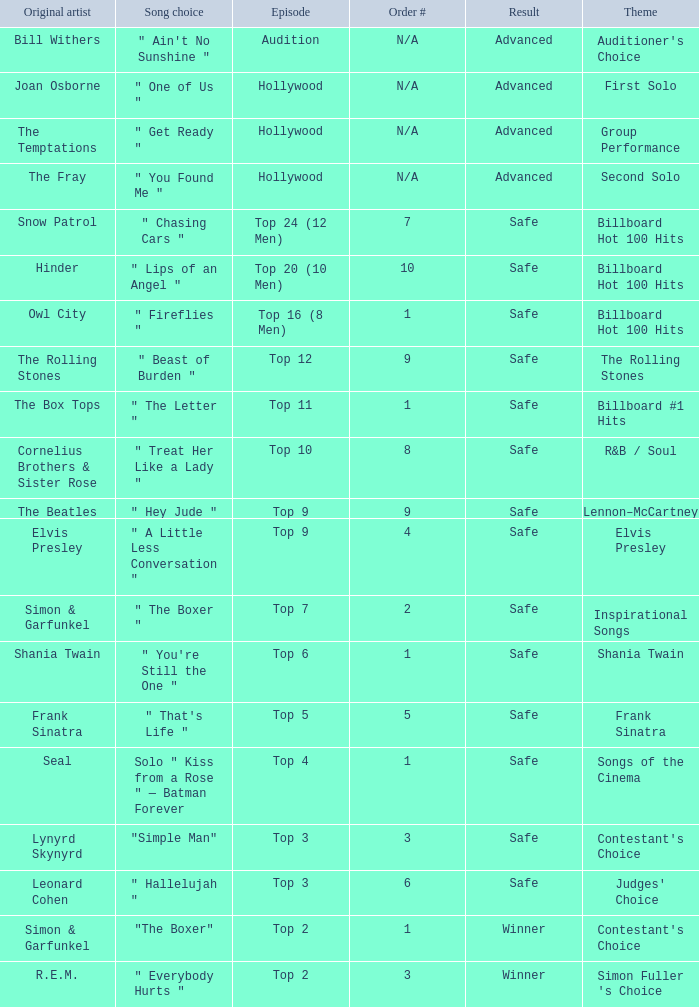In which episode is the order number 10? Top 20 (10 Men). Parse the full table. {'header': ['Original artist', 'Song choice', 'Episode', 'Order #', 'Result', 'Theme'], 'rows': [['Bill Withers', '" Ain\'t No Sunshine "', 'Audition', 'N/A', 'Advanced', "Auditioner's Choice"], ['Joan Osborne', '" One of Us "', 'Hollywood', 'N/A', 'Advanced', 'First Solo'], ['The Temptations', '" Get Ready "', 'Hollywood', 'N/A', 'Advanced', 'Group Performance'], ['The Fray', '" You Found Me "', 'Hollywood', 'N/A', 'Advanced', 'Second Solo'], ['Snow Patrol', '" Chasing Cars "', 'Top 24 (12 Men)', '7', 'Safe', 'Billboard Hot 100 Hits'], ['Hinder', '" Lips of an Angel "', 'Top 20 (10 Men)', '10', 'Safe', 'Billboard Hot 100 Hits'], ['Owl City', '" Fireflies "', 'Top 16 (8 Men)', '1', 'Safe', 'Billboard Hot 100 Hits'], ['The Rolling Stones', '" Beast of Burden "', 'Top 12', '9', 'Safe', 'The Rolling Stones'], ['The Box Tops', '" The Letter "', 'Top 11', '1', 'Safe', 'Billboard #1 Hits'], ['Cornelius Brothers & Sister Rose', '" Treat Her Like a Lady "', 'Top 10', '8', 'Safe', 'R&B / Soul'], ['The Beatles', '" Hey Jude "', 'Top 9', '9', 'Safe', 'Lennon–McCartney'], ['Elvis Presley', '" A Little Less Conversation "', 'Top 9', '4', 'Safe', 'Elvis Presley'], ['Simon & Garfunkel', '" The Boxer "', 'Top 7', '2', 'Safe', 'Inspirational Songs'], ['Shania Twain', '" You\'re Still the One "', 'Top 6', '1', 'Safe', 'Shania Twain'], ['Frank Sinatra', '" That\'s Life "', 'Top 5', '5', 'Safe', 'Frank Sinatra'], ['Seal', 'Solo " Kiss from a Rose " — Batman Forever', 'Top 4', '1', 'Safe', 'Songs of the Cinema'], ['Lynyrd Skynyrd', '"Simple Man"', 'Top 3', '3', 'Safe', "Contestant's Choice"], ['Leonard Cohen', '" Hallelujah "', 'Top 3', '6', 'Safe', "Judges' Choice"], ['Simon & Garfunkel', '"The Boxer"', 'Top 2', '1', 'Winner', "Contestant's Choice"], ['R.E.M.', '" Everybody Hurts "', 'Top 2', '3', 'Winner', "Simon Fuller 's Choice"]]} 